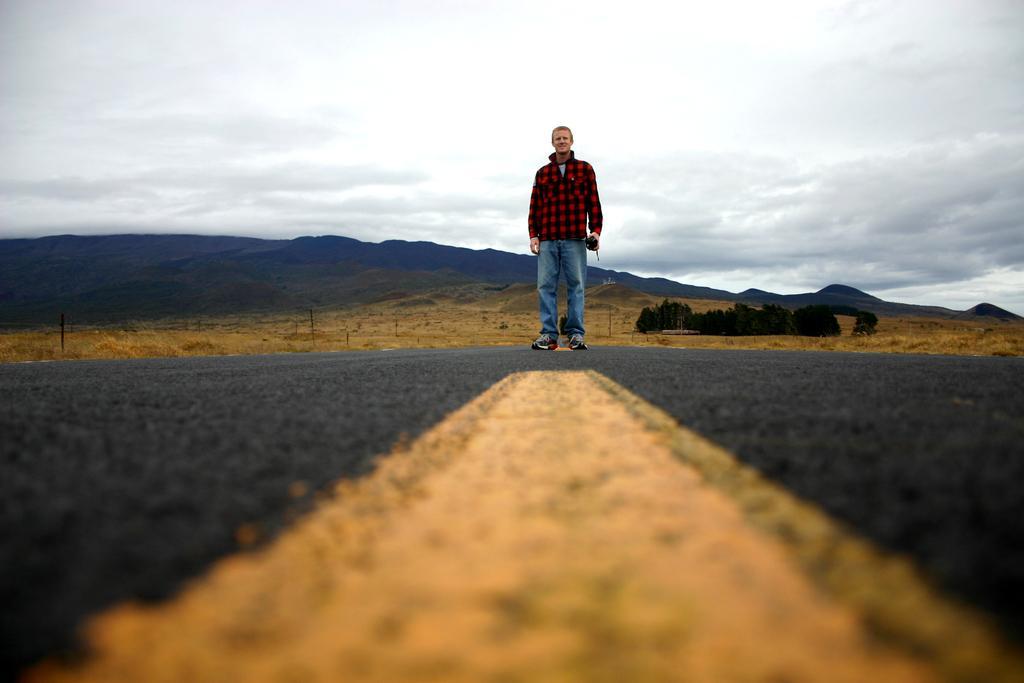Please provide a concise description of this image. In the middle of the image we can see a man and he is holding an object, in the background we can see few trees, hills and clouds. 